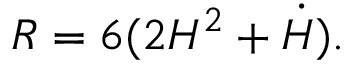<formula> <loc_0><loc_0><loc_500><loc_500>R = 6 ( 2 H ^ { 2 } + \dot { H } ) .</formula> 